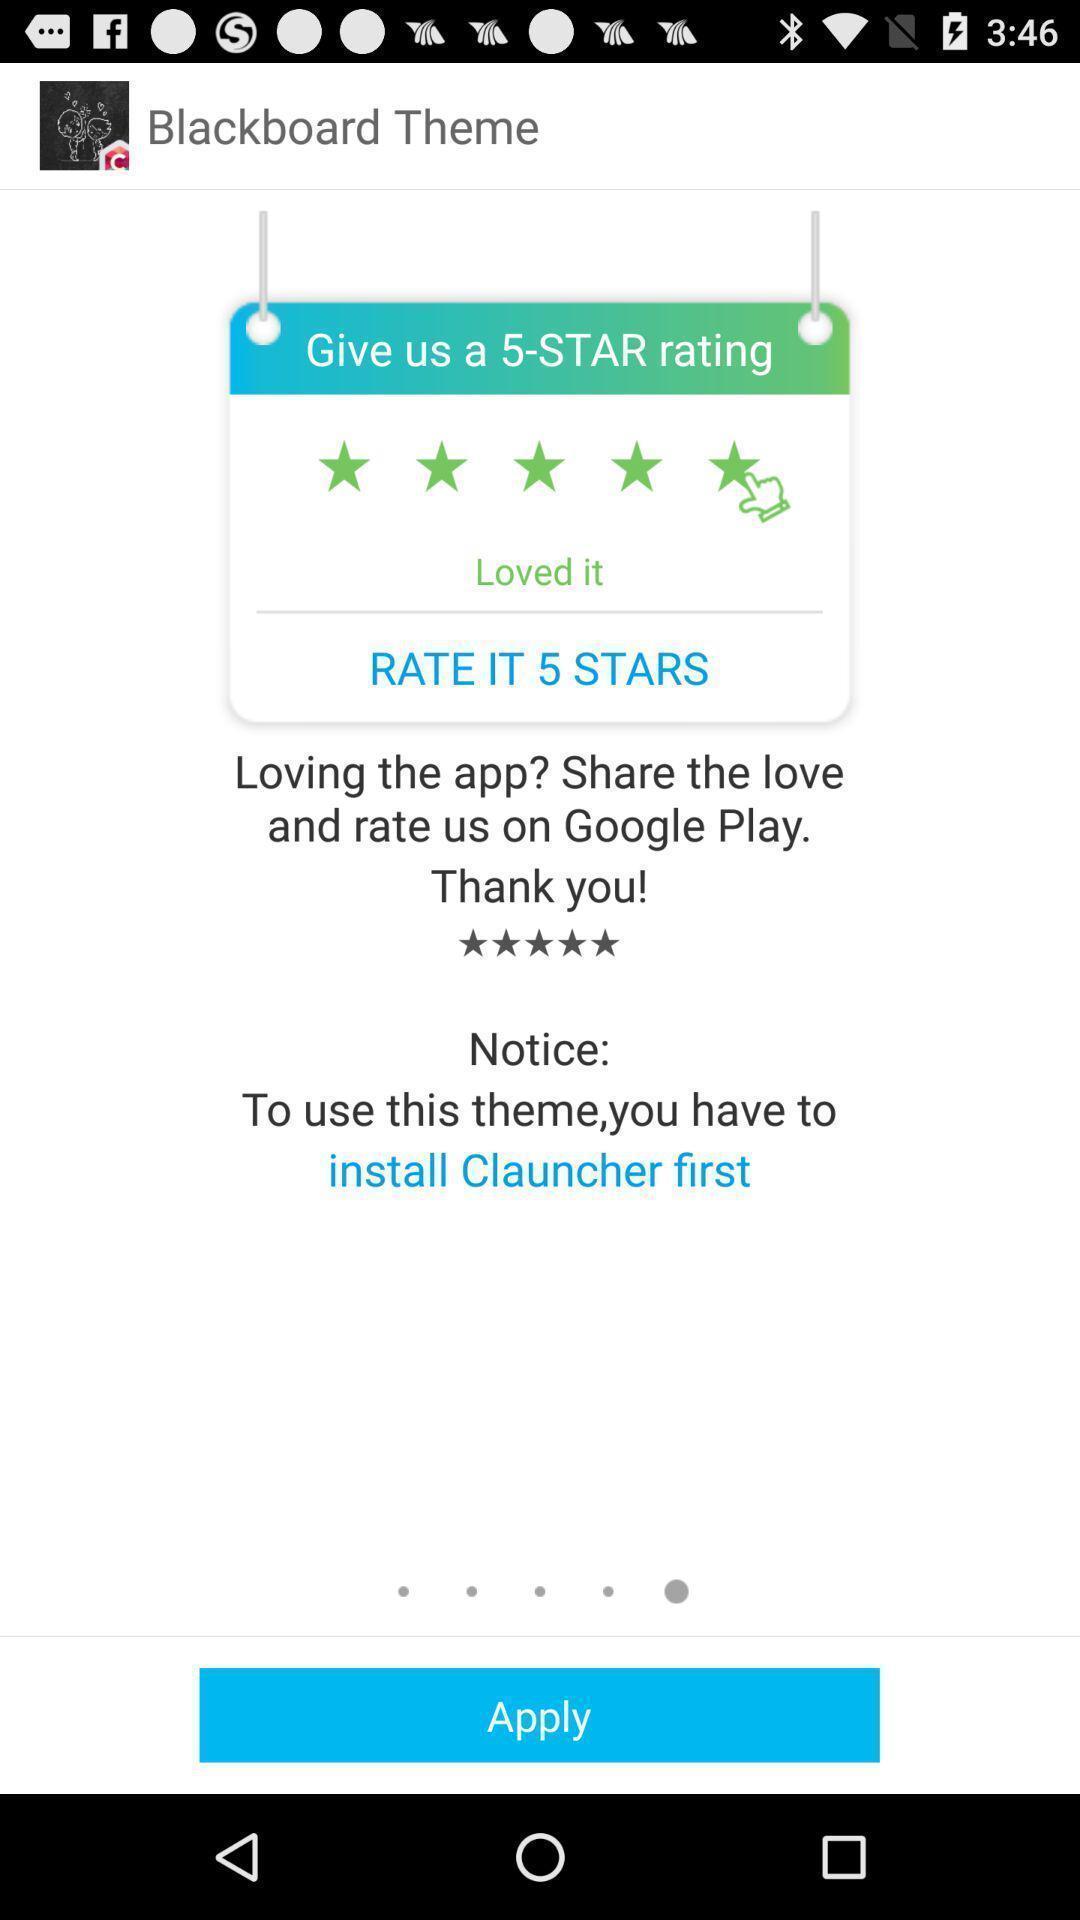Give me a narrative description of this picture. Page showing blackboard theme with apply button. 